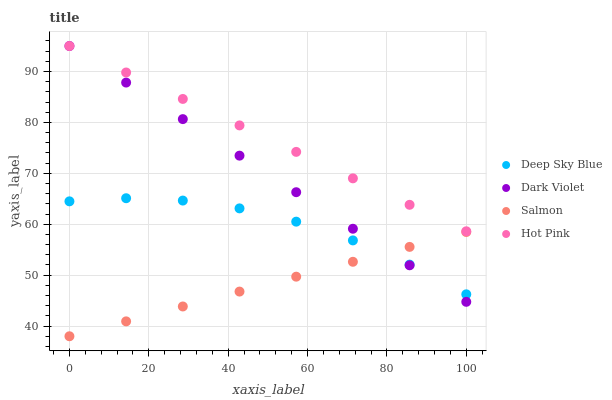Does Salmon have the minimum area under the curve?
Answer yes or no. Yes. Does Hot Pink have the maximum area under the curve?
Answer yes or no. Yes. Does Dark Violet have the minimum area under the curve?
Answer yes or no. No. Does Dark Violet have the maximum area under the curve?
Answer yes or no. No. Is Hot Pink the smoothest?
Answer yes or no. Yes. Is Deep Sky Blue the roughest?
Answer yes or no. Yes. Is Salmon the smoothest?
Answer yes or no. No. Is Salmon the roughest?
Answer yes or no. No. Does Salmon have the lowest value?
Answer yes or no. Yes. Does Dark Violet have the lowest value?
Answer yes or no. No. Does Dark Violet have the highest value?
Answer yes or no. Yes. Does Salmon have the highest value?
Answer yes or no. No. Is Deep Sky Blue less than Hot Pink?
Answer yes or no. Yes. Is Hot Pink greater than Deep Sky Blue?
Answer yes or no. Yes. Does Deep Sky Blue intersect Dark Violet?
Answer yes or no. Yes. Is Deep Sky Blue less than Dark Violet?
Answer yes or no. No. Is Deep Sky Blue greater than Dark Violet?
Answer yes or no. No. Does Deep Sky Blue intersect Hot Pink?
Answer yes or no. No. 